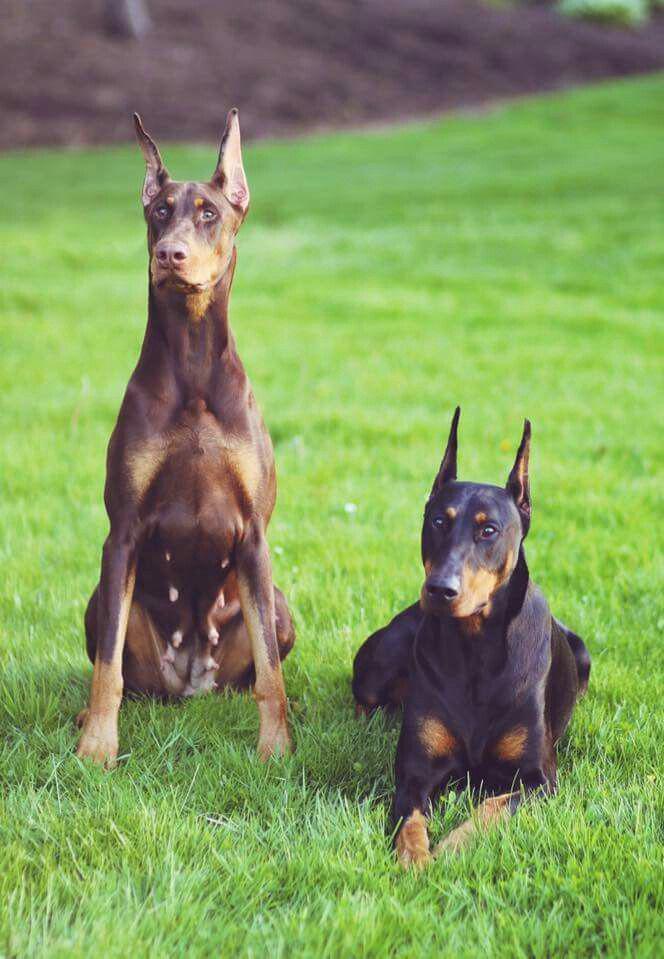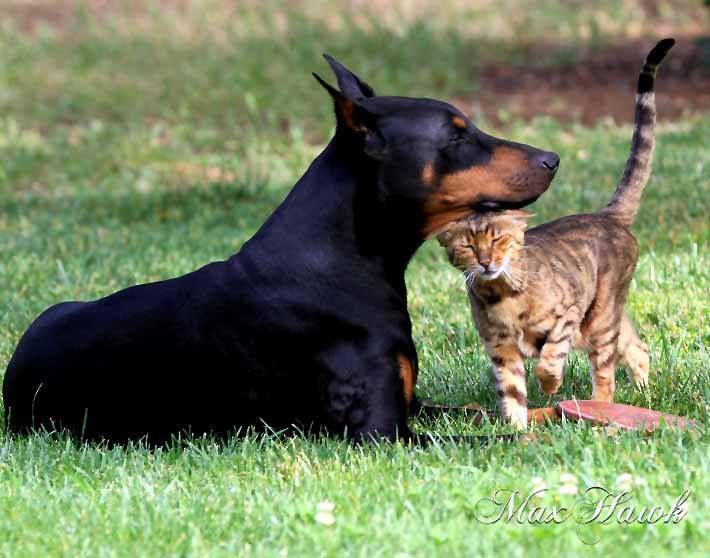The first image is the image on the left, the second image is the image on the right. Assess this claim about the two images: "One image contains one pointy-eared doberman in a reclining pose with upright head, and the other image features side-by-side pointy-eared dobermans - one brown and one black-and-tan.". Correct or not? Answer yes or no. Yes. The first image is the image on the left, the second image is the image on the right. For the images shown, is this caption "One image shows a single dog lying on grass with its front paws extended and crossed." true? Answer yes or no. No. 